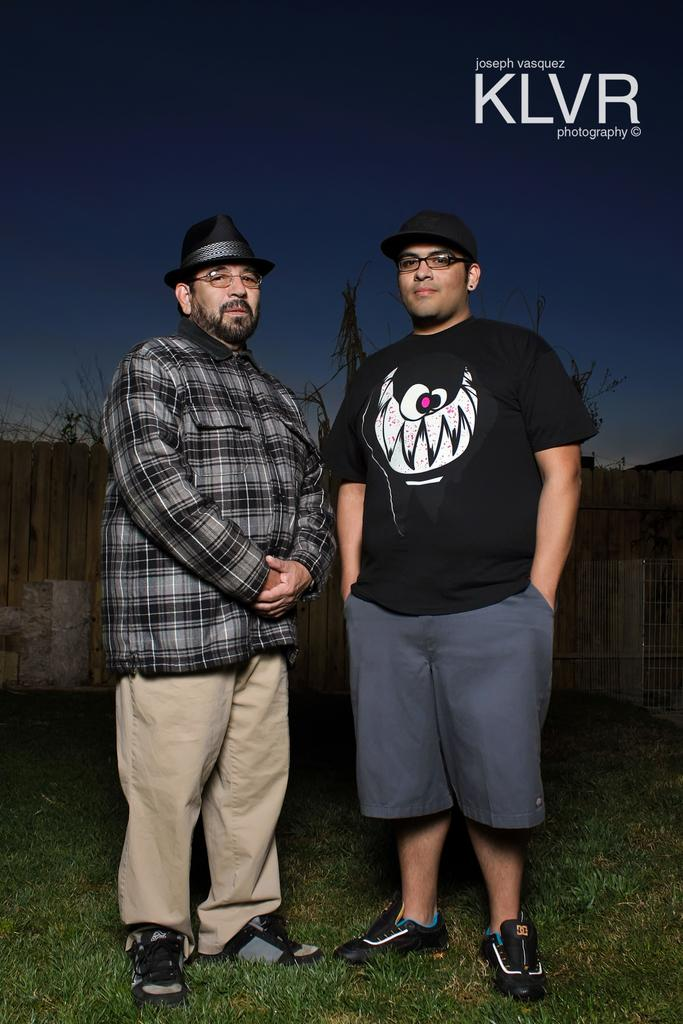How many people are in the foreground of the image? There are two men standing in the foreground of the image. What is the terrain where the men are standing? The men are standing on grassland. What can be seen in the background of the image? There are trees and a wooden boundary in the background of the image. What is visible above the trees and wooden boundary? The sky is visible in the background of the image. What type of tank can be seen in the image? There is no tank present in the image. Are the two men in the image engaged in a fight? The image does not show any indication of a fight between the two men. 